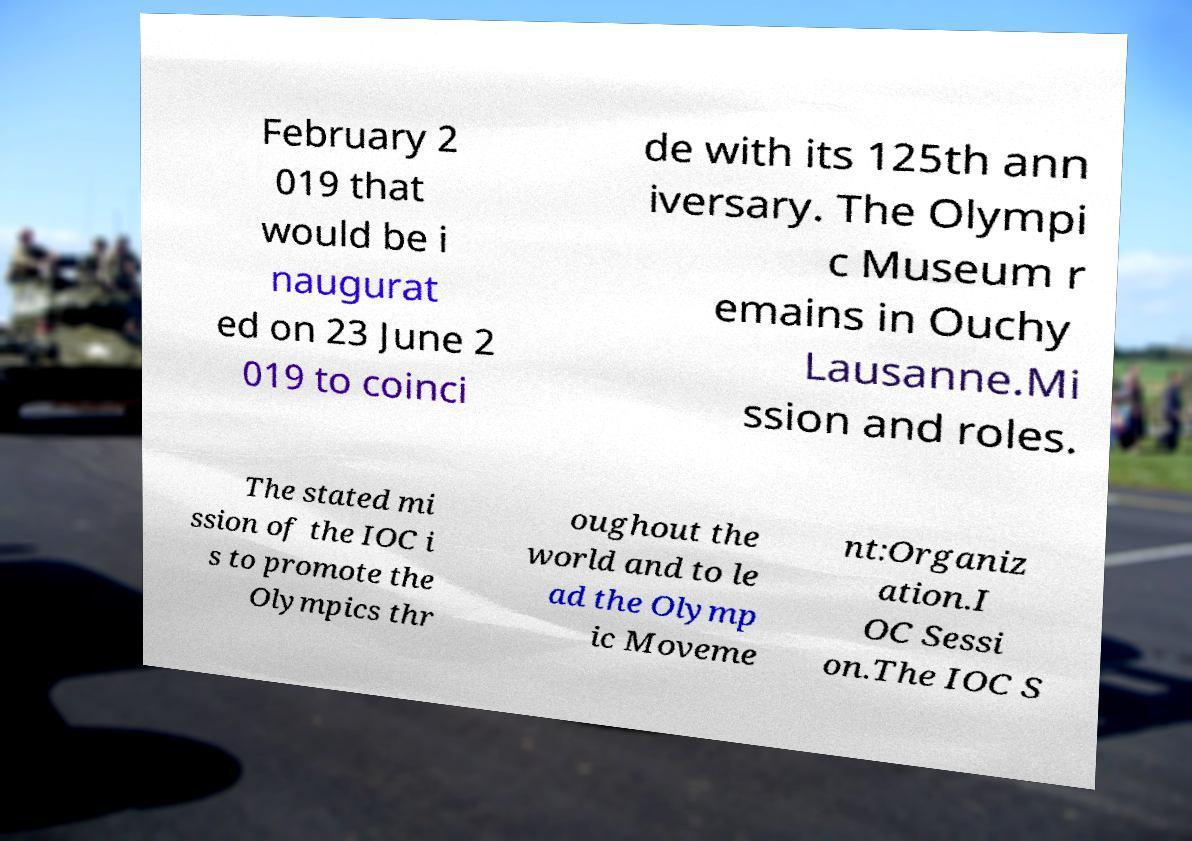I need the written content from this picture converted into text. Can you do that? February 2 019 that would be i naugurat ed on 23 June 2 019 to coinci de with its 125th ann iversary. The Olympi c Museum r emains in Ouchy Lausanne.Mi ssion and roles. The stated mi ssion of the IOC i s to promote the Olympics thr oughout the world and to le ad the Olymp ic Moveme nt:Organiz ation.I OC Sessi on.The IOC S 